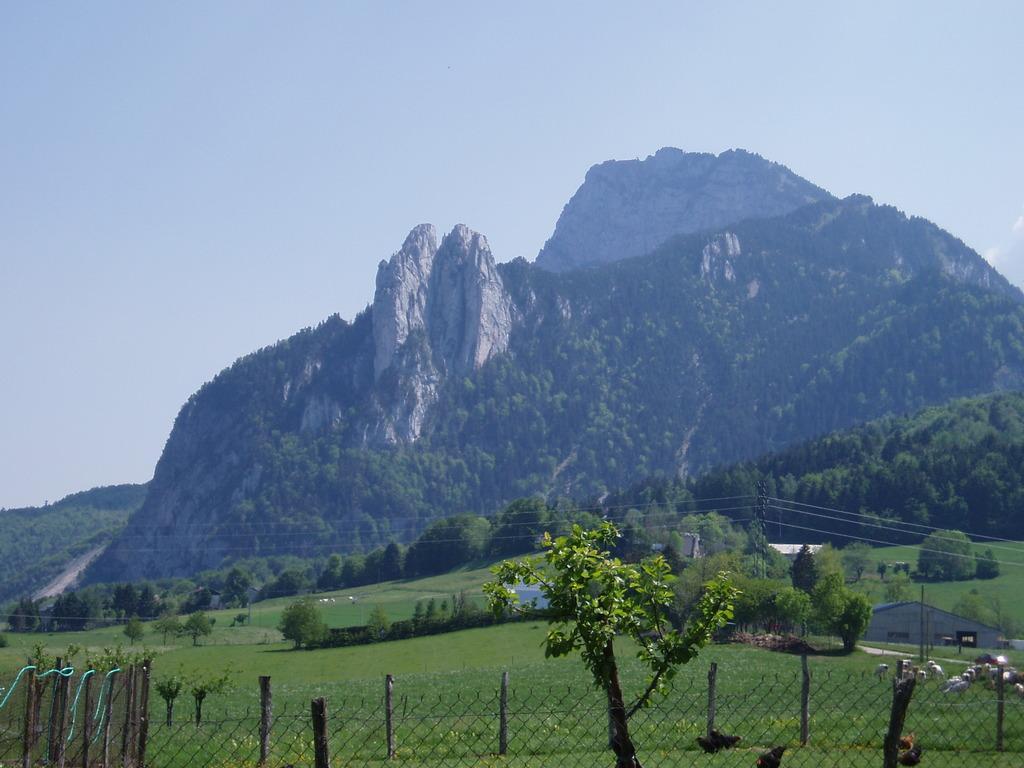Describe this image in one or two sentences. In this picture I can see many trees, plants and grass. On the right I can see the shed. In the bottom right corner I can see the sheep who are eating the grass. In the background I can see the mountains. At the top I can see the sky. At the bottom I can see the fencing. 